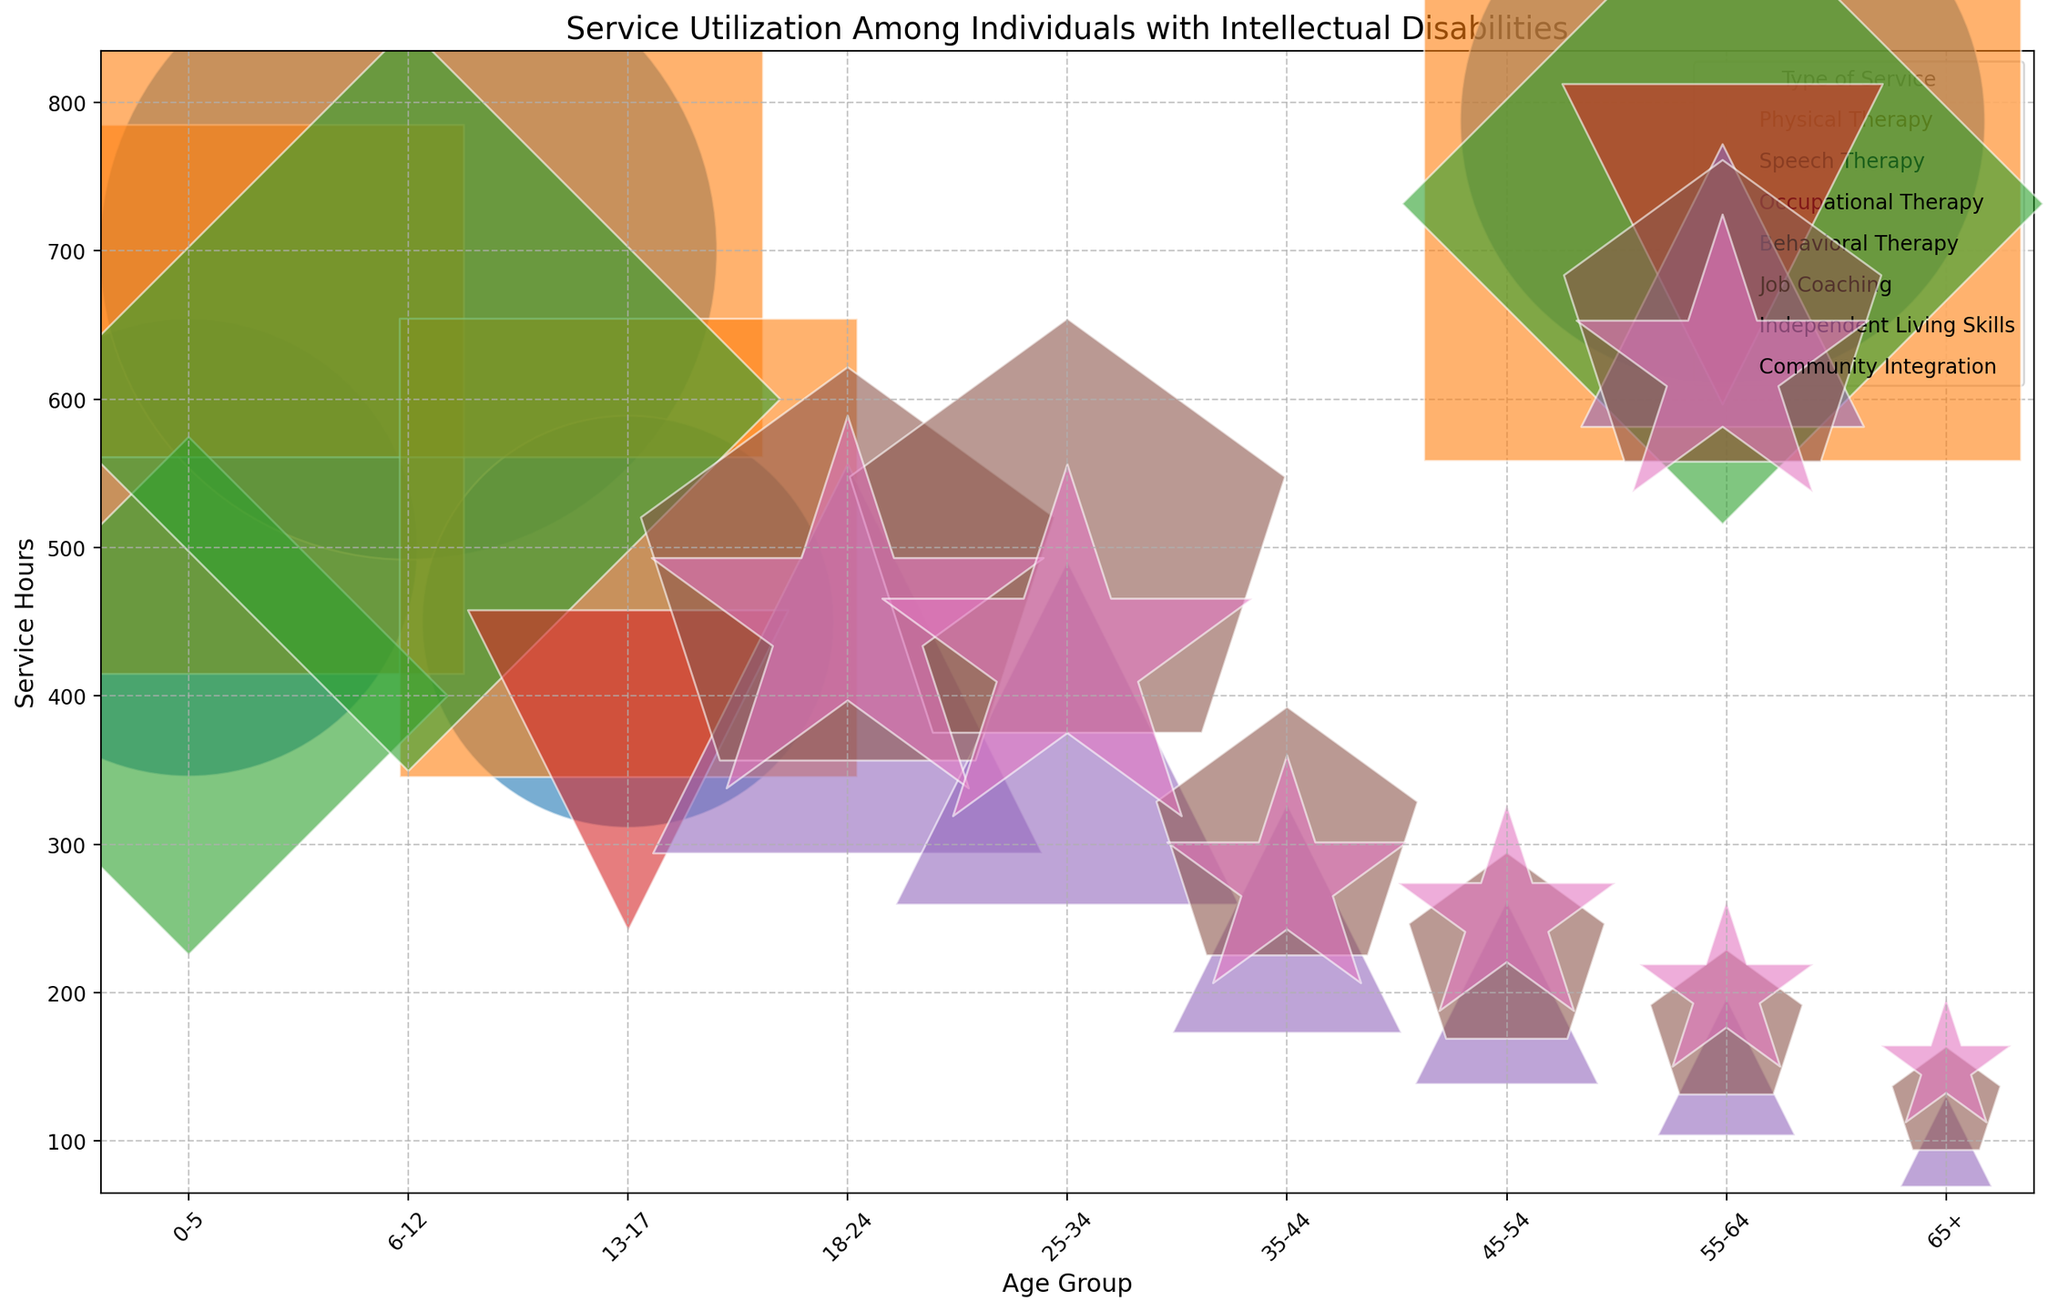What age group has the highest service hours for Physical Therapy? To find this, locate the bubbles corresponding to Physical Therapy and compare the service hours for different age groups. The bubble at 6-12 age group has 700 service hours, which is the highest.
Answer: 6-12 Which type of service has the largest bubble size in the 0-5 age group? By observing the 0-5 age group axis, identify which service has the largest bubble. Speech Therapy has the largest bubble size of 72000.
Answer: Speech Therapy What is the total number of individuals in the 25-34 age group for all services? To get this, sum the number of individuals for all services in the 25-34 age group: Job Coaching (75), Independent Living Skills (100), and Community Integration (85). 75 + 100 + 85 = 260.
Answer: 260 How does the number of individuals participating in Speech Therapy change from the 0-5 age group to the 6-12 age group? Compare the number of individuals in Speech Therapy for these age groups: 120 individuals in 0-5 and 150 in 6-12. The change is 150 - 120 = 30.
Answer: +30 Which service is used by the most number of individuals in the 13-17 age group? To find the answer, look at the number of individuals for each service in the 13-17 age group. Speech Therapy has the highest with 100 individuals.
Answer: Speech Therapy What is the difference in the bubble size between Job Coaching and Independent Living Skills for the 55-64 age group? Locate the bubble sizes for Job Coaching (4500) and Independent Living Skills (6125) in the 55-64 age group. Calculate the difference: 6125 - 4500 = 1625.
Answer: 1625 Which age group has the least total service hours across all services? Sum the service hours for all services in each age group and determine the smallest value. The 65+ age group has Job Coaching (100), Independent Living Skills (125), and Community Integration (150). Their total is 100 + 125 + 150 = 375, which is the smallest.
Answer: 65+ How does the total service hours for Community Integration vary between 18-24 and 45-54 age groups? For the 18-24 age group, Community Integration has 450 service hours. For the 45-54 age group, it has 250 service hours. The difference is 450 - 250 = 200.
Answer: 200 Which type of service for the 18-24 age group has the smallest bubble size? Observing the bubbles for the 18-24 age group, Community Integration has the smallest bubble size of 40500.
Answer: Community Integration 